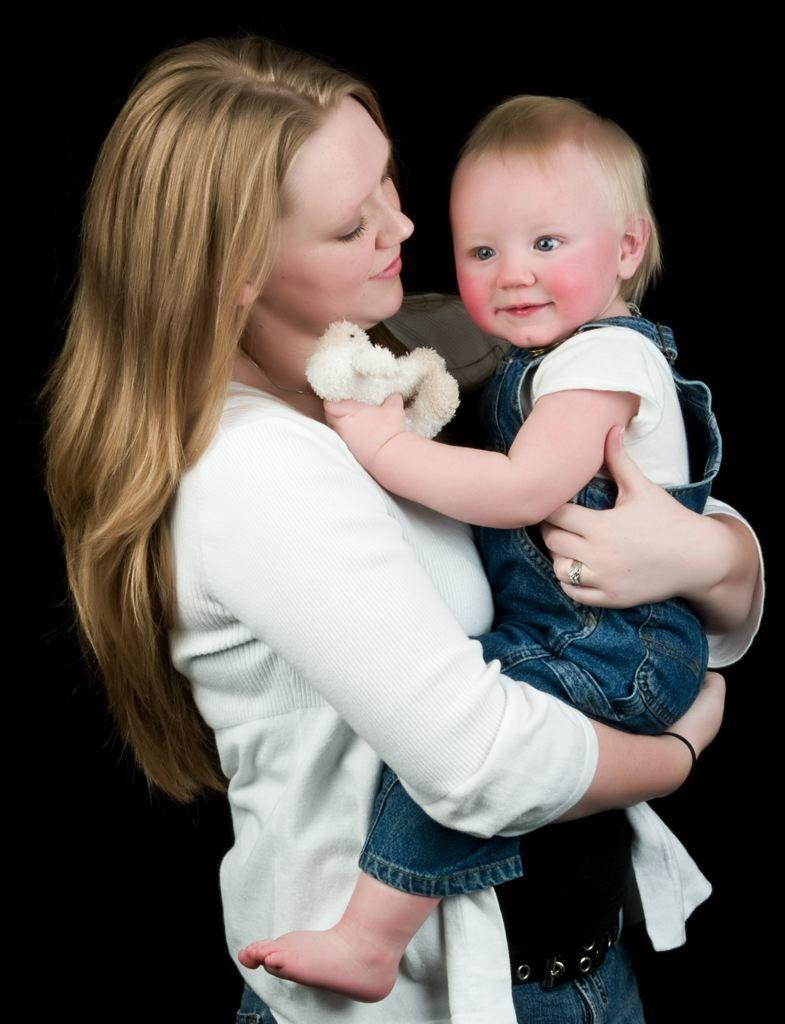How many people are present in the image? There are two people in the image. Can you describe the positioning of one of the people? One person is partially cut off at the bottom. What is one of the people doing in the image? One person is holding an object. What can be observed about the background of the image? The background of the image is dark. What type of salt can be seen on the person's hand in the image? There is no salt visible on anyone's hand in the image. Can you describe the bee that is buzzing around the person holding the object? There are no bees present in the image. 